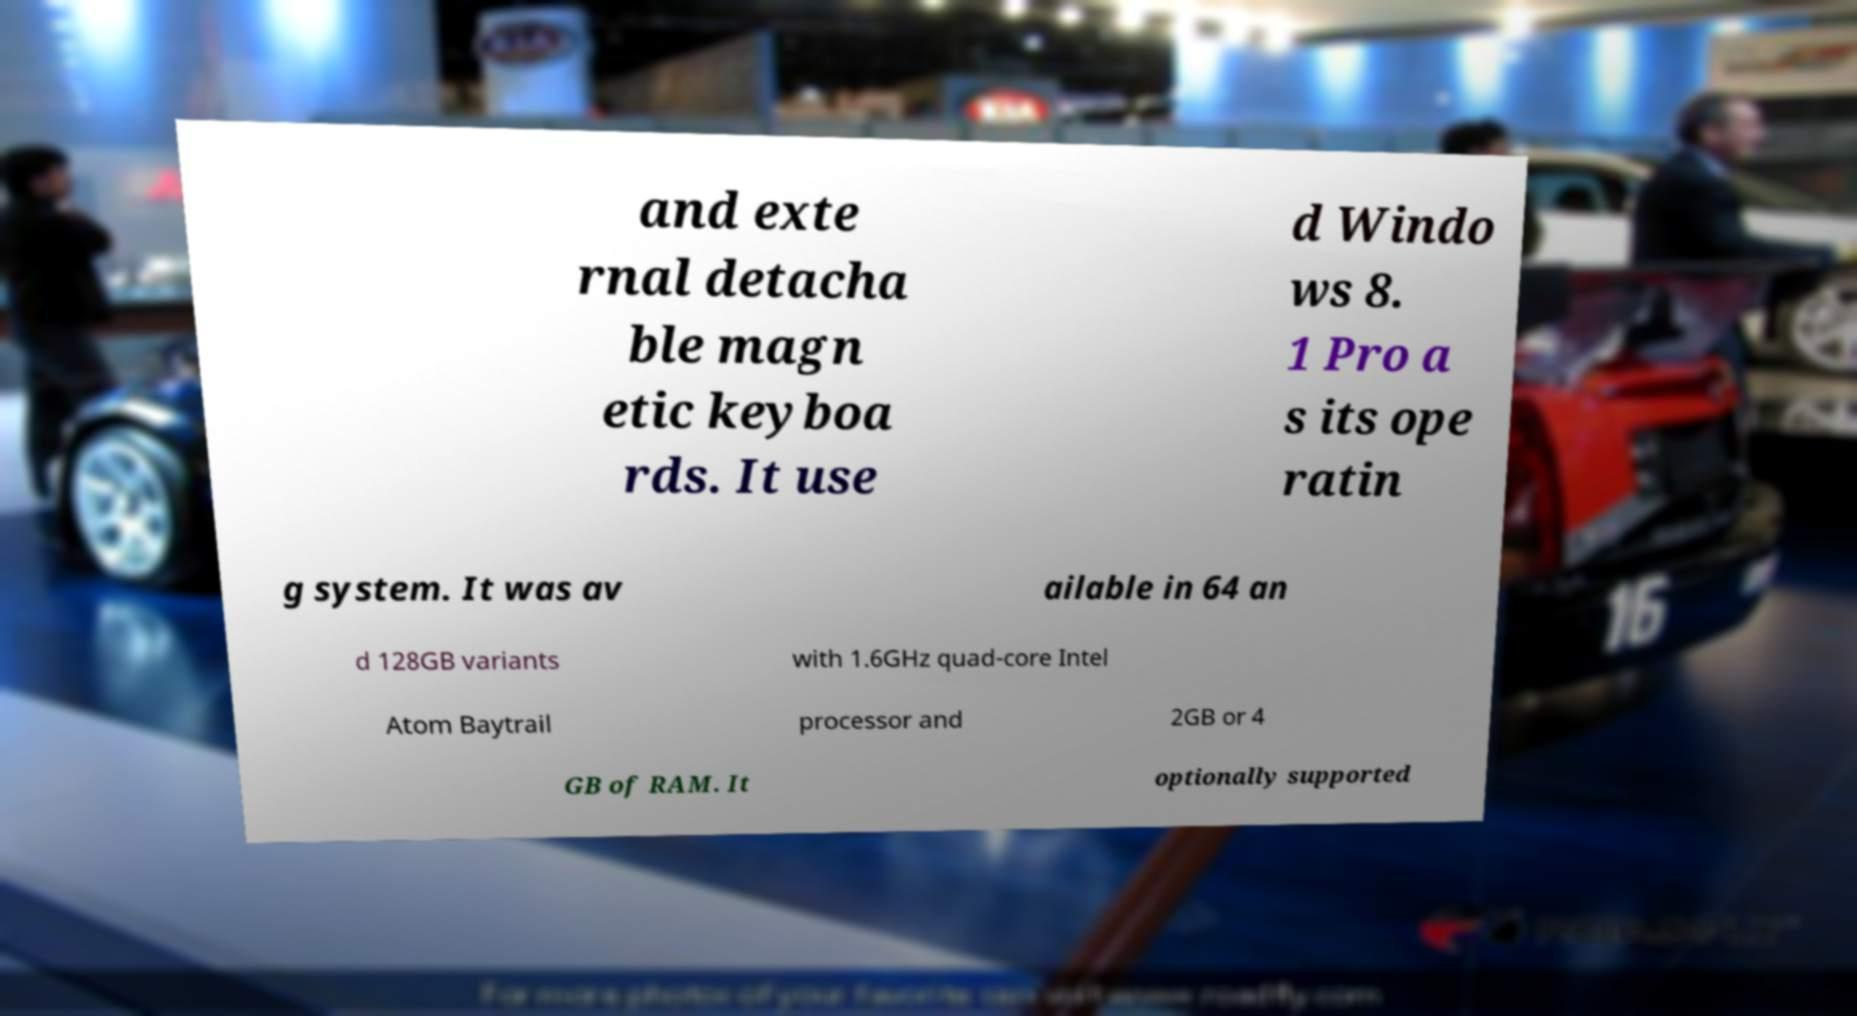Please identify and transcribe the text found in this image. and exte rnal detacha ble magn etic keyboa rds. It use d Windo ws 8. 1 Pro a s its ope ratin g system. It was av ailable in 64 an d 128GB variants with 1.6GHz quad-core Intel Atom Baytrail processor and 2GB or 4 GB of RAM. It optionally supported 